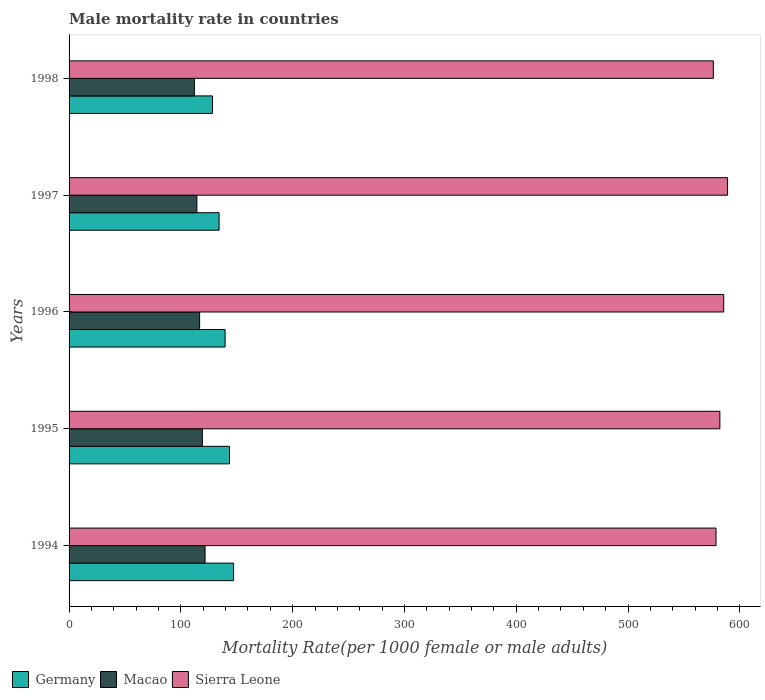How many groups of bars are there?
Your answer should be compact. 5. Are the number of bars on each tick of the Y-axis equal?
Provide a succinct answer. Yes. How many bars are there on the 4th tick from the top?
Provide a short and direct response. 3. What is the label of the 5th group of bars from the top?
Your answer should be very brief. 1994. What is the male mortality rate in Germany in 1997?
Offer a terse response. 134.2. Across all years, what is the maximum male mortality rate in Sierra Leone?
Offer a terse response. 589.05. Across all years, what is the minimum male mortality rate in Sierra Leone?
Your answer should be very brief. 576.3. In which year was the male mortality rate in Macao maximum?
Make the answer very short. 1994. In which year was the male mortality rate in Germany minimum?
Ensure brevity in your answer.  1998. What is the total male mortality rate in Germany in the graph?
Offer a terse response. 692.72. What is the difference between the male mortality rate in Sierra Leone in 1996 and that in 1997?
Provide a short and direct response. -3.45. What is the difference between the male mortality rate in Sierra Leone in 1998 and the male mortality rate in Germany in 1997?
Your answer should be compact. 442.1. What is the average male mortality rate in Sierra Leone per year?
Make the answer very short. 582.37. In the year 1998, what is the difference between the male mortality rate in Germany and male mortality rate in Sierra Leone?
Provide a succinct answer. -448.01. What is the ratio of the male mortality rate in Macao in 1997 to that in 1998?
Offer a very short reply. 1.02. Is the difference between the male mortality rate in Germany in 1994 and 1998 greater than the difference between the male mortality rate in Sierra Leone in 1994 and 1998?
Offer a very short reply. Yes. What is the difference between the highest and the second highest male mortality rate in Sierra Leone?
Your answer should be very brief. 3.45. What is the difference between the highest and the lowest male mortality rate in Macao?
Make the answer very short. 9.55. In how many years, is the male mortality rate in Macao greater than the average male mortality rate in Macao taken over all years?
Ensure brevity in your answer.  2. What does the 2nd bar from the top in 1998 represents?
Keep it short and to the point. Macao. Is it the case that in every year, the sum of the male mortality rate in Macao and male mortality rate in Sierra Leone is greater than the male mortality rate in Germany?
Offer a very short reply. Yes. How many bars are there?
Ensure brevity in your answer.  15. Are the values on the major ticks of X-axis written in scientific E-notation?
Offer a terse response. No. Does the graph contain any zero values?
Ensure brevity in your answer.  No. How many legend labels are there?
Your response must be concise. 3. How are the legend labels stacked?
Ensure brevity in your answer.  Horizontal. What is the title of the graph?
Offer a terse response. Male mortality rate in countries. What is the label or title of the X-axis?
Ensure brevity in your answer.  Mortality Rate(per 1000 female or male adults). What is the Mortality Rate(per 1000 female or male adults) in Germany in 1994?
Your answer should be very brief. 147.17. What is the Mortality Rate(per 1000 female or male adults) in Macao in 1994?
Your answer should be very brief. 121.66. What is the Mortality Rate(per 1000 female or male adults) of Sierra Leone in 1994?
Your response must be concise. 578.72. What is the Mortality Rate(per 1000 female or male adults) in Germany in 1995?
Make the answer very short. 143.49. What is the Mortality Rate(per 1000 female or male adults) in Macao in 1995?
Ensure brevity in your answer.  119.21. What is the Mortality Rate(per 1000 female or male adults) in Sierra Leone in 1995?
Your response must be concise. 582.16. What is the Mortality Rate(per 1000 female or male adults) in Germany in 1996?
Offer a terse response. 139.57. What is the Mortality Rate(per 1000 female or male adults) of Macao in 1996?
Your answer should be very brief. 116.77. What is the Mortality Rate(per 1000 female or male adults) of Sierra Leone in 1996?
Offer a terse response. 585.61. What is the Mortality Rate(per 1000 female or male adults) of Germany in 1997?
Provide a short and direct response. 134.2. What is the Mortality Rate(per 1000 female or male adults) in Macao in 1997?
Provide a short and direct response. 114.33. What is the Mortality Rate(per 1000 female or male adults) of Sierra Leone in 1997?
Keep it short and to the point. 589.05. What is the Mortality Rate(per 1000 female or male adults) in Germany in 1998?
Offer a terse response. 128.29. What is the Mortality Rate(per 1000 female or male adults) in Macao in 1998?
Offer a terse response. 112.11. What is the Mortality Rate(per 1000 female or male adults) in Sierra Leone in 1998?
Make the answer very short. 576.3. Across all years, what is the maximum Mortality Rate(per 1000 female or male adults) in Germany?
Make the answer very short. 147.17. Across all years, what is the maximum Mortality Rate(per 1000 female or male adults) in Macao?
Offer a terse response. 121.66. Across all years, what is the maximum Mortality Rate(per 1000 female or male adults) in Sierra Leone?
Offer a terse response. 589.05. Across all years, what is the minimum Mortality Rate(per 1000 female or male adults) of Germany?
Provide a short and direct response. 128.29. Across all years, what is the minimum Mortality Rate(per 1000 female or male adults) in Macao?
Offer a terse response. 112.11. Across all years, what is the minimum Mortality Rate(per 1000 female or male adults) in Sierra Leone?
Your answer should be compact. 576.3. What is the total Mortality Rate(per 1000 female or male adults) of Germany in the graph?
Provide a short and direct response. 692.72. What is the total Mortality Rate(per 1000 female or male adults) in Macao in the graph?
Offer a terse response. 584.08. What is the total Mortality Rate(per 1000 female or male adults) in Sierra Leone in the graph?
Keep it short and to the point. 2911.84. What is the difference between the Mortality Rate(per 1000 female or male adults) of Germany in 1994 and that in 1995?
Provide a short and direct response. 3.68. What is the difference between the Mortality Rate(per 1000 female or male adults) of Macao in 1994 and that in 1995?
Provide a succinct answer. 2.44. What is the difference between the Mortality Rate(per 1000 female or male adults) of Sierra Leone in 1994 and that in 1995?
Offer a very short reply. -3.44. What is the difference between the Mortality Rate(per 1000 female or male adults) in Germany in 1994 and that in 1996?
Offer a very short reply. 7.6. What is the difference between the Mortality Rate(per 1000 female or male adults) in Macao in 1994 and that in 1996?
Provide a short and direct response. 4.89. What is the difference between the Mortality Rate(per 1000 female or male adults) in Sierra Leone in 1994 and that in 1996?
Ensure brevity in your answer.  -6.89. What is the difference between the Mortality Rate(per 1000 female or male adults) in Germany in 1994 and that in 1997?
Your answer should be compact. 12.97. What is the difference between the Mortality Rate(per 1000 female or male adults) of Macao in 1994 and that in 1997?
Keep it short and to the point. 7.33. What is the difference between the Mortality Rate(per 1000 female or male adults) of Sierra Leone in 1994 and that in 1997?
Ensure brevity in your answer.  -10.34. What is the difference between the Mortality Rate(per 1000 female or male adults) of Germany in 1994 and that in 1998?
Give a very brief answer. 18.88. What is the difference between the Mortality Rate(per 1000 female or male adults) in Macao in 1994 and that in 1998?
Offer a terse response. 9.55. What is the difference between the Mortality Rate(per 1000 female or male adults) in Sierra Leone in 1994 and that in 1998?
Offer a terse response. 2.42. What is the difference between the Mortality Rate(per 1000 female or male adults) in Germany in 1995 and that in 1996?
Your answer should be compact. 3.92. What is the difference between the Mortality Rate(per 1000 female or male adults) in Macao in 1995 and that in 1996?
Your response must be concise. 2.44. What is the difference between the Mortality Rate(per 1000 female or male adults) of Sierra Leone in 1995 and that in 1996?
Ensure brevity in your answer.  -3.44. What is the difference between the Mortality Rate(per 1000 female or male adults) in Germany in 1995 and that in 1997?
Your answer should be very brief. 9.3. What is the difference between the Mortality Rate(per 1000 female or male adults) in Macao in 1995 and that in 1997?
Your response must be concise. 4.89. What is the difference between the Mortality Rate(per 1000 female or male adults) in Sierra Leone in 1995 and that in 1997?
Your answer should be compact. -6.89. What is the difference between the Mortality Rate(per 1000 female or male adults) in Germany in 1995 and that in 1998?
Offer a very short reply. 15.21. What is the difference between the Mortality Rate(per 1000 female or male adults) of Macao in 1995 and that in 1998?
Your response must be concise. 7.11. What is the difference between the Mortality Rate(per 1000 female or male adults) in Sierra Leone in 1995 and that in 1998?
Provide a short and direct response. 5.86. What is the difference between the Mortality Rate(per 1000 female or male adults) of Germany in 1996 and that in 1997?
Your answer should be compact. 5.38. What is the difference between the Mortality Rate(per 1000 female or male adults) of Macao in 1996 and that in 1997?
Your response must be concise. 2.44. What is the difference between the Mortality Rate(per 1000 female or male adults) of Sierra Leone in 1996 and that in 1997?
Keep it short and to the point. -3.44. What is the difference between the Mortality Rate(per 1000 female or male adults) of Germany in 1996 and that in 1998?
Your response must be concise. 11.29. What is the difference between the Mortality Rate(per 1000 female or male adults) in Macao in 1996 and that in 1998?
Provide a succinct answer. 4.66. What is the difference between the Mortality Rate(per 1000 female or male adults) of Sierra Leone in 1996 and that in 1998?
Keep it short and to the point. 9.31. What is the difference between the Mortality Rate(per 1000 female or male adults) of Germany in 1997 and that in 1998?
Provide a succinct answer. 5.91. What is the difference between the Mortality Rate(per 1000 female or male adults) of Macao in 1997 and that in 1998?
Offer a terse response. 2.22. What is the difference between the Mortality Rate(per 1000 female or male adults) in Sierra Leone in 1997 and that in 1998?
Offer a very short reply. 12.75. What is the difference between the Mortality Rate(per 1000 female or male adults) in Germany in 1994 and the Mortality Rate(per 1000 female or male adults) in Macao in 1995?
Provide a short and direct response. 27.96. What is the difference between the Mortality Rate(per 1000 female or male adults) in Germany in 1994 and the Mortality Rate(per 1000 female or male adults) in Sierra Leone in 1995?
Make the answer very short. -434.99. What is the difference between the Mortality Rate(per 1000 female or male adults) in Macao in 1994 and the Mortality Rate(per 1000 female or male adults) in Sierra Leone in 1995?
Your response must be concise. -460.5. What is the difference between the Mortality Rate(per 1000 female or male adults) of Germany in 1994 and the Mortality Rate(per 1000 female or male adults) of Macao in 1996?
Your response must be concise. 30.4. What is the difference between the Mortality Rate(per 1000 female or male adults) of Germany in 1994 and the Mortality Rate(per 1000 female or male adults) of Sierra Leone in 1996?
Keep it short and to the point. -438.44. What is the difference between the Mortality Rate(per 1000 female or male adults) in Macao in 1994 and the Mortality Rate(per 1000 female or male adults) in Sierra Leone in 1996?
Make the answer very short. -463.95. What is the difference between the Mortality Rate(per 1000 female or male adults) of Germany in 1994 and the Mortality Rate(per 1000 female or male adults) of Macao in 1997?
Keep it short and to the point. 32.84. What is the difference between the Mortality Rate(per 1000 female or male adults) of Germany in 1994 and the Mortality Rate(per 1000 female or male adults) of Sierra Leone in 1997?
Give a very brief answer. -441.88. What is the difference between the Mortality Rate(per 1000 female or male adults) of Macao in 1994 and the Mortality Rate(per 1000 female or male adults) of Sierra Leone in 1997?
Offer a very short reply. -467.39. What is the difference between the Mortality Rate(per 1000 female or male adults) of Germany in 1994 and the Mortality Rate(per 1000 female or male adults) of Macao in 1998?
Your answer should be compact. 35.06. What is the difference between the Mortality Rate(per 1000 female or male adults) in Germany in 1994 and the Mortality Rate(per 1000 female or male adults) in Sierra Leone in 1998?
Give a very brief answer. -429.13. What is the difference between the Mortality Rate(per 1000 female or male adults) of Macao in 1994 and the Mortality Rate(per 1000 female or male adults) of Sierra Leone in 1998?
Give a very brief answer. -454.64. What is the difference between the Mortality Rate(per 1000 female or male adults) of Germany in 1995 and the Mortality Rate(per 1000 female or male adults) of Macao in 1996?
Make the answer very short. 26.72. What is the difference between the Mortality Rate(per 1000 female or male adults) in Germany in 1995 and the Mortality Rate(per 1000 female or male adults) in Sierra Leone in 1996?
Offer a terse response. -442.11. What is the difference between the Mortality Rate(per 1000 female or male adults) in Macao in 1995 and the Mortality Rate(per 1000 female or male adults) in Sierra Leone in 1996?
Make the answer very short. -466.39. What is the difference between the Mortality Rate(per 1000 female or male adults) in Germany in 1995 and the Mortality Rate(per 1000 female or male adults) in Macao in 1997?
Your response must be concise. 29.17. What is the difference between the Mortality Rate(per 1000 female or male adults) of Germany in 1995 and the Mortality Rate(per 1000 female or male adults) of Sierra Leone in 1997?
Your response must be concise. -445.56. What is the difference between the Mortality Rate(per 1000 female or male adults) of Macao in 1995 and the Mortality Rate(per 1000 female or male adults) of Sierra Leone in 1997?
Provide a succinct answer. -469.84. What is the difference between the Mortality Rate(per 1000 female or male adults) in Germany in 1995 and the Mortality Rate(per 1000 female or male adults) in Macao in 1998?
Make the answer very short. 31.39. What is the difference between the Mortality Rate(per 1000 female or male adults) in Germany in 1995 and the Mortality Rate(per 1000 female or male adults) in Sierra Leone in 1998?
Make the answer very short. -432.81. What is the difference between the Mortality Rate(per 1000 female or male adults) in Macao in 1995 and the Mortality Rate(per 1000 female or male adults) in Sierra Leone in 1998?
Offer a very short reply. -457.09. What is the difference between the Mortality Rate(per 1000 female or male adults) of Germany in 1996 and the Mortality Rate(per 1000 female or male adults) of Macao in 1997?
Your answer should be compact. 25.25. What is the difference between the Mortality Rate(per 1000 female or male adults) of Germany in 1996 and the Mortality Rate(per 1000 female or male adults) of Sierra Leone in 1997?
Provide a succinct answer. -449.48. What is the difference between the Mortality Rate(per 1000 female or male adults) of Macao in 1996 and the Mortality Rate(per 1000 female or male adults) of Sierra Leone in 1997?
Offer a very short reply. -472.28. What is the difference between the Mortality Rate(per 1000 female or male adults) in Germany in 1996 and the Mortality Rate(per 1000 female or male adults) in Macao in 1998?
Your answer should be very brief. 27.46. What is the difference between the Mortality Rate(per 1000 female or male adults) of Germany in 1996 and the Mortality Rate(per 1000 female or male adults) of Sierra Leone in 1998?
Offer a very short reply. -436.73. What is the difference between the Mortality Rate(per 1000 female or male adults) in Macao in 1996 and the Mortality Rate(per 1000 female or male adults) in Sierra Leone in 1998?
Your answer should be very brief. -459.53. What is the difference between the Mortality Rate(per 1000 female or male adults) of Germany in 1997 and the Mortality Rate(per 1000 female or male adults) of Macao in 1998?
Keep it short and to the point. 22.09. What is the difference between the Mortality Rate(per 1000 female or male adults) of Germany in 1997 and the Mortality Rate(per 1000 female or male adults) of Sierra Leone in 1998?
Give a very brief answer. -442.11. What is the difference between the Mortality Rate(per 1000 female or male adults) in Macao in 1997 and the Mortality Rate(per 1000 female or male adults) in Sierra Leone in 1998?
Provide a succinct answer. -461.98. What is the average Mortality Rate(per 1000 female or male adults) of Germany per year?
Keep it short and to the point. 138.54. What is the average Mortality Rate(per 1000 female or male adults) of Macao per year?
Give a very brief answer. 116.82. What is the average Mortality Rate(per 1000 female or male adults) in Sierra Leone per year?
Offer a very short reply. 582.37. In the year 1994, what is the difference between the Mortality Rate(per 1000 female or male adults) in Germany and Mortality Rate(per 1000 female or male adults) in Macao?
Keep it short and to the point. 25.51. In the year 1994, what is the difference between the Mortality Rate(per 1000 female or male adults) of Germany and Mortality Rate(per 1000 female or male adults) of Sierra Leone?
Keep it short and to the point. -431.55. In the year 1994, what is the difference between the Mortality Rate(per 1000 female or male adults) in Macao and Mortality Rate(per 1000 female or male adults) in Sierra Leone?
Make the answer very short. -457.06. In the year 1995, what is the difference between the Mortality Rate(per 1000 female or male adults) in Germany and Mortality Rate(per 1000 female or male adults) in Macao?
Your answer should be very brief. 24.28. In the year 1995, what is the difference between the Mortality Rate(per 1000 female or male adults) of Germany and Mortality Rate(per 1000 female or male adults) of Sierra Leone?
Keep it short and to the point. -438.67. In the year 1995, what is the difference between the Mortality Rate(per 1000 female or male adults) in Macao and Mortality Rate(per 1000 female or male adults) in Sierra Leone?
Offer a very short reply. -462.95. In the year 1996, what is the difference between the Mortality Rate(per 1000 female or male adults) of Germany and Mortality Rate(per 1000 female or male adults) of Macao?
Provide a short and direct response. 22.8. In the year 1996, what is the difference between the Mortality Rate(per 1000 female or male adults) in Germany and Mortality Rate(per 1000 female or male adults) in Sierra Leone?
Your answer should be compact. -446.03. In the year 1996, what is the difference between the Mortality Rate(per 1000 female or male adults) in Macao and Mortality Rate(per 1000 female or male adults) in Sierra Leone?
Offer a terse response. -468.84. In the year 1997, what is the difference between the Mortality Rate(per 1000 female or male adults) in Germany and Mortality Rate(per 1000 female or male adults) in Macao?
Keep it short and to the point. 19.87. In the year 1997, what is the difference between the Mortality Rate(per 1000 female or male adults) in Germany and Mortality Rate(per 1000 female or male adults) in Sierra Leone?
Offer a very short reply. -454.86. In the year 1997, what is the difference between the Mortality Rate(per 1000 female or male adults) of Macao and Mortality Rate(per 1000 female or male adults) of Sierra Leone?
Provide a short and direct response. -474.73. In the year 1998, what is the difference between the Mortality Rate(per 1000 female or male adults) in Germany and Mortality Rate(per 1000 female or male adults) in Macao?
Make the answer very short. 16.18. In the year 1998, what is the difference between the Mortality Rate(per 1000 female or male adults) of Germany and Mortality Rate(per 1000 female or male adults) of Sierra Leone?
Your answer should be very brief. -448.01. In the year 1998, what is the difference between the Mortality Rate(per 1000 female or male adults) in Macao and Mortality Rate(per 1000 female or male adults) in Sierra Leone?
Provide a short and direct response. -464.19. What is the ratio of the Mortality Rate(per 1000 female or male adults) of Germany in 1994 to that in 1995?
Your answer should be compact. 1.03. What is the ratio of the Mortality Rate(per 1000 female or male adults) of Macao in 1994 to that in 1995?
Keep it short and to the point. 1.02. What is the ratio of the Mortality Rate(per 1000 female or male adults) of Germany in 1994 to that in 1996?
Offer a very short reply. 1.05. What is the ratio of the Mortality Rate(per 1000 female or male adults) in Macao in 1994 to that in 1996?
Give a very brief answer. 1.04. What is the ratio of the Mortality Rate(per 1000 female or male adults) of Germany in 1994 to that in 1997?
Provide a succinct answer. 1.1. What is the ratio of the Mortality Rate(per 1000 female or male adults) of Macao in 1994 to that in 1997?
Offer a terse response. 1.06. What is the ratio of the Mortality Rate(per 1000 female or male adults) of Sierra Leone in 1994 to that in 1997?
Your response must be concise. 0.98. What is the ratio of the Mortality Rate(per 1000 female or male adults) of Germany in 1994 to that in 1998?
Your response must be concise. 1.15. What is the ratio of the Mortality Rate(per 1000 female or male adults) in Macao in 1994 to that in 1998?
Provide a succinct answer. 1.09. What is the ratio of the Mortality Rate(per 1000 female or male adults) of Sierra Leone in 1994 to that in 1998?
Your answer should be compact. 1. What is the ratio of the Mortality Rate(per 1000 female or male adults) in Germany in 1995 to that in 1996?
Offer a very short reply. 1.03. What is the ratio of the Mortality Rate(per 1000 female or male adults) in Macao in 1995 to that in 1996?
Make the answer very short. 1.02. What is the ratio of the Mortality Rate(per 1000 female or male adults) of Sierra Leone in 1995 to that in 1996?
Your answer should be compact. 0.99. What is the ratio of the Mortality Rate(per 1000 female or male adults) in Germany in 1995 to that in 1997?
Offer a terse response. 1.07. What is the ratio of the Mortality Rate(per 1000 female or male adults) in Macao in 1995 to that in 1997?
Your answer should be compact. 1.04. What is the ratio of the Mortality Rate(per 1000 female or male adults) in Sierra Leone in 1995 to that in 1997?
Offer a terse response. 0.99. What is the ratio of the Mortality Rate(per 1000 female or male adults) of Germany in 1995 to that in 1998?
Give a very brief answer. 1.12. What is the ratio of the Mortality Rate(per 1000 female or male adults) of Macao in 1995 to that in 1998?
Make the answer very short. 1.06. What is the ratio of the Mortality Rate(per 1000 female or male adults) in Sierra Leone in 1995 to that in 1998?
Offer a terse response. 1.01. What is the ratio of the Mortality Rate(per 1000 female or male adults) of Germany in 1996 to that in 1997?
Your answer should be compact. 1.04. What is the ratio of the Mortality Rate(per 1000 female or male adults) of Macao in 1996 to that in 1997?
Your answer should be compact. 1.02. What is the ratio of the Mortality Rate(per 1000 female or male adults) of Sierra Leone in 1996 to that in 1997?
Ensure brevity in your answer.  0.99. What is the ratio of the Mortality Rate(per 1000 female or male adults) in Germany in 1996 to that in 1998?
Provide a short and direct response. 1.09. What is the ratio of the Mortality Rate(per 1000 female or male adults) of Macao in 1996 to that in 1998?
Keep it short and to the point. 1.04. What is the ratio of the Mortality Rate(per 1000 female or male adults) of Sierra Leone in 1996 to that in 1998?
Provide a succinct answer. 1.02. What is the ratio of the Mortality Rate(per 1000 female or male adults) in Germany in 1997 to that in 1998?
Your answer should be very brief. 1.05. What is the ratio of the Mortality Rate(per 1000 female or male adults) of Macao in 1997 to that in 1998?
Provide a short and direct response. 1.02. What is the ratio of the Mortality Rate(per 1000 female or male adults) in Sierra Leone in 1997 to that in 1998?
Provide a short and direct response. 1.02. What is the difference between the highest and the second highest Mortality Rate(per 1000 female or male adults) of Germany?
Your response must be concise. 3.68. What is the difference between the highest and the second highest Mortality Rate(per 1000 female or male adults) in Macao?
Offer a very short reply. 2.44. What is the difference between the highest and the second highest Mortality Rate(per 1000 female or male adults) in Sierra Leone?
Give a very brief answer. 3.44. What is the difference between the highest and the lowest Mortality Rate(per 1000 female or male adults) of Germany?
Make the answer very short. 18.88. What is the difference between the highest and the lowest Mortality Rate(per 1000 female or male adults) of Macao?
Make the answer very short. 9.55. What is the difference between the highest and the lowest Mortality Rate(per 1000 female or male adults) of Sierra Leone?
Offer a very short reply. 12.75. 